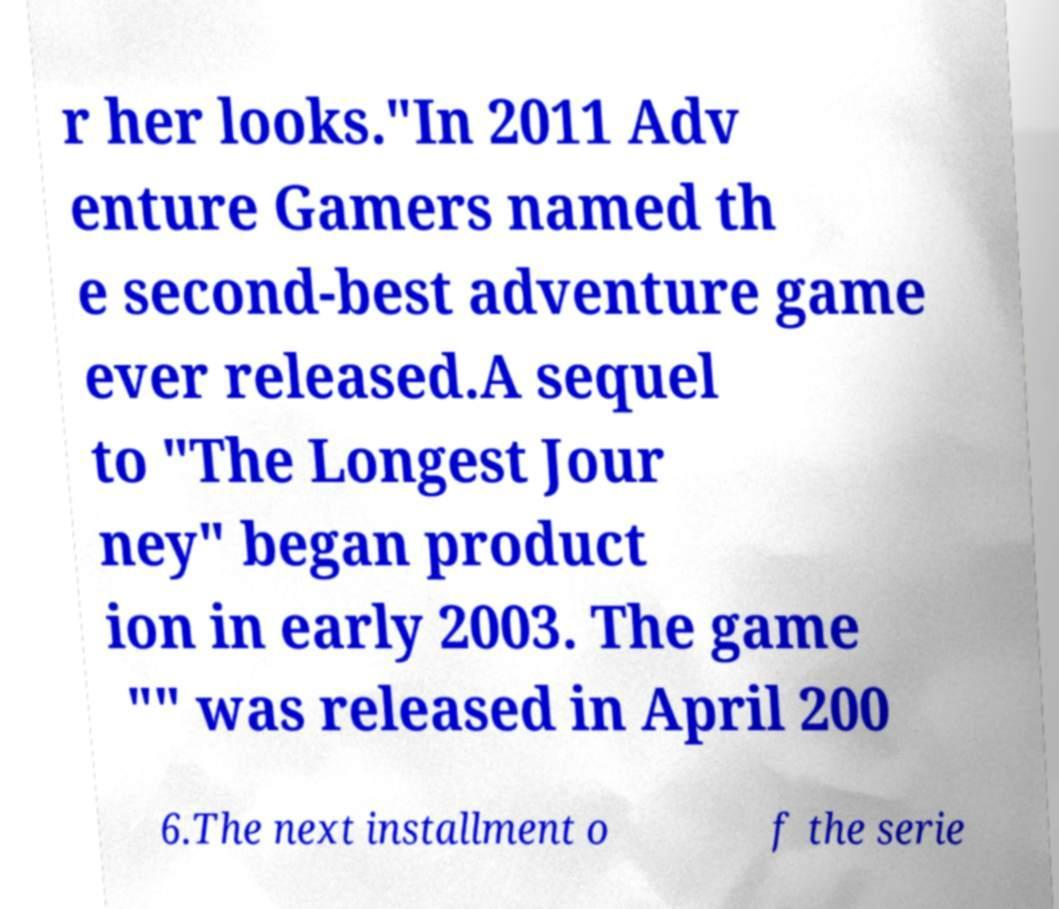Could you assist in decoding the text presented in this image and type it out clearly? r her looks."In 2011 Adv enture Gamers named th e second-best adventure game ever released.A sequel to "The Longest Jour ney" began product ion in early 2003. The game "" was released in April 200 6.The next installment o f the serie 